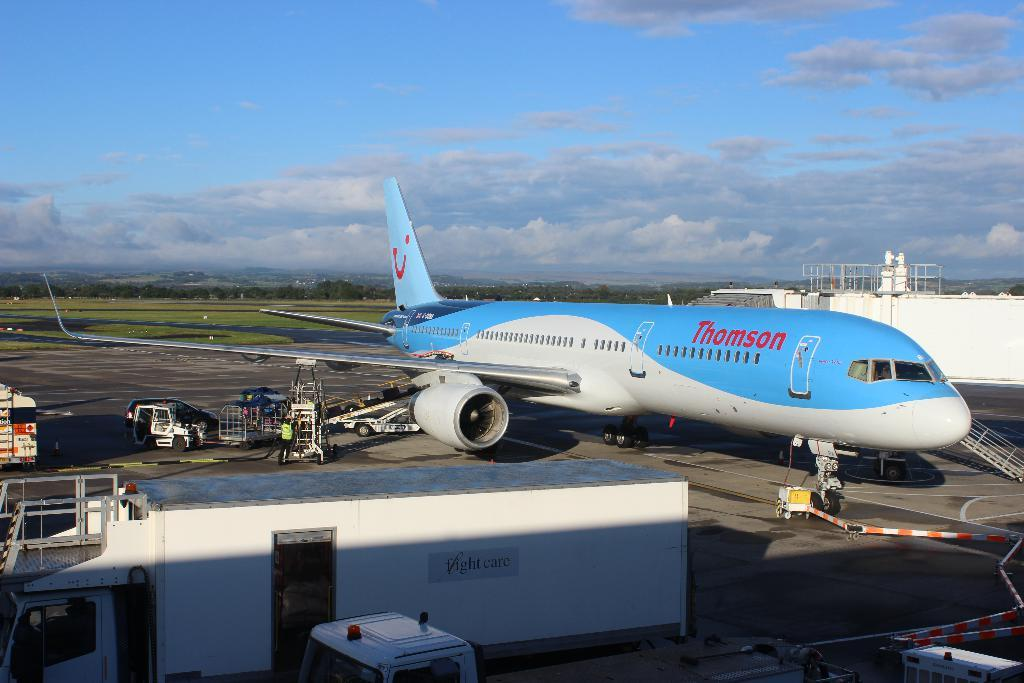<image>
Give a short and clear explanation of the subsequent image. A airplane with a flowing multicolored paint job is part of the Thomson fleet. 